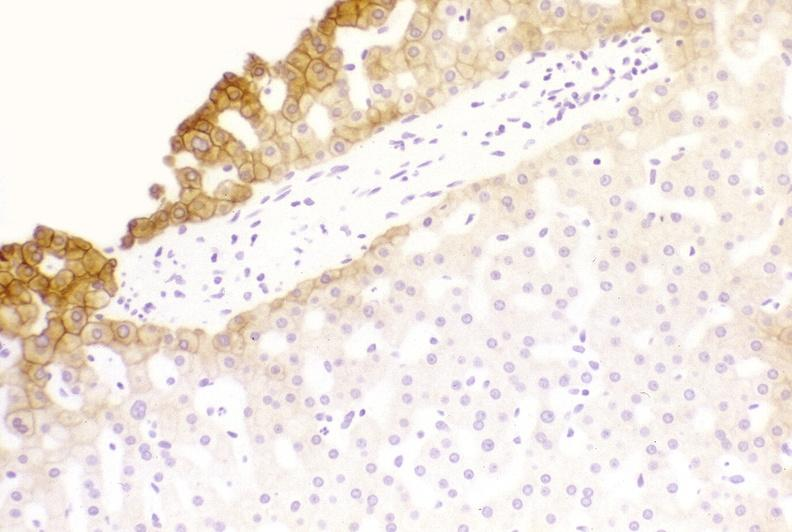s liver present?
Answer the question using a single word or phrase. Yes 